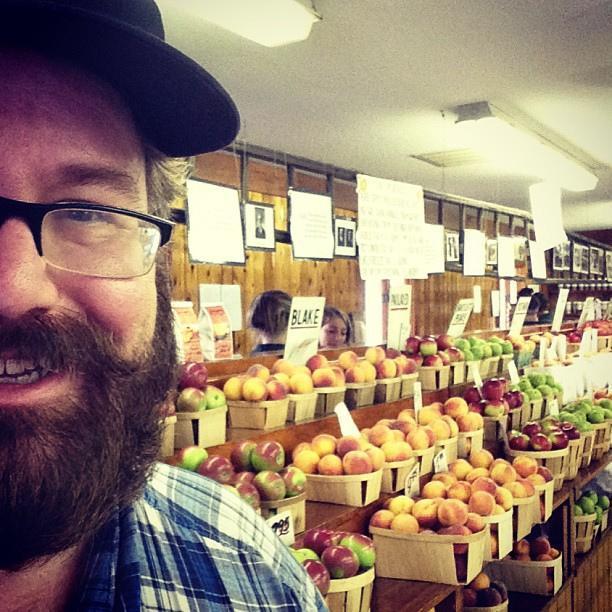How many people are in the picture?
Give a very brief answer. 2. 